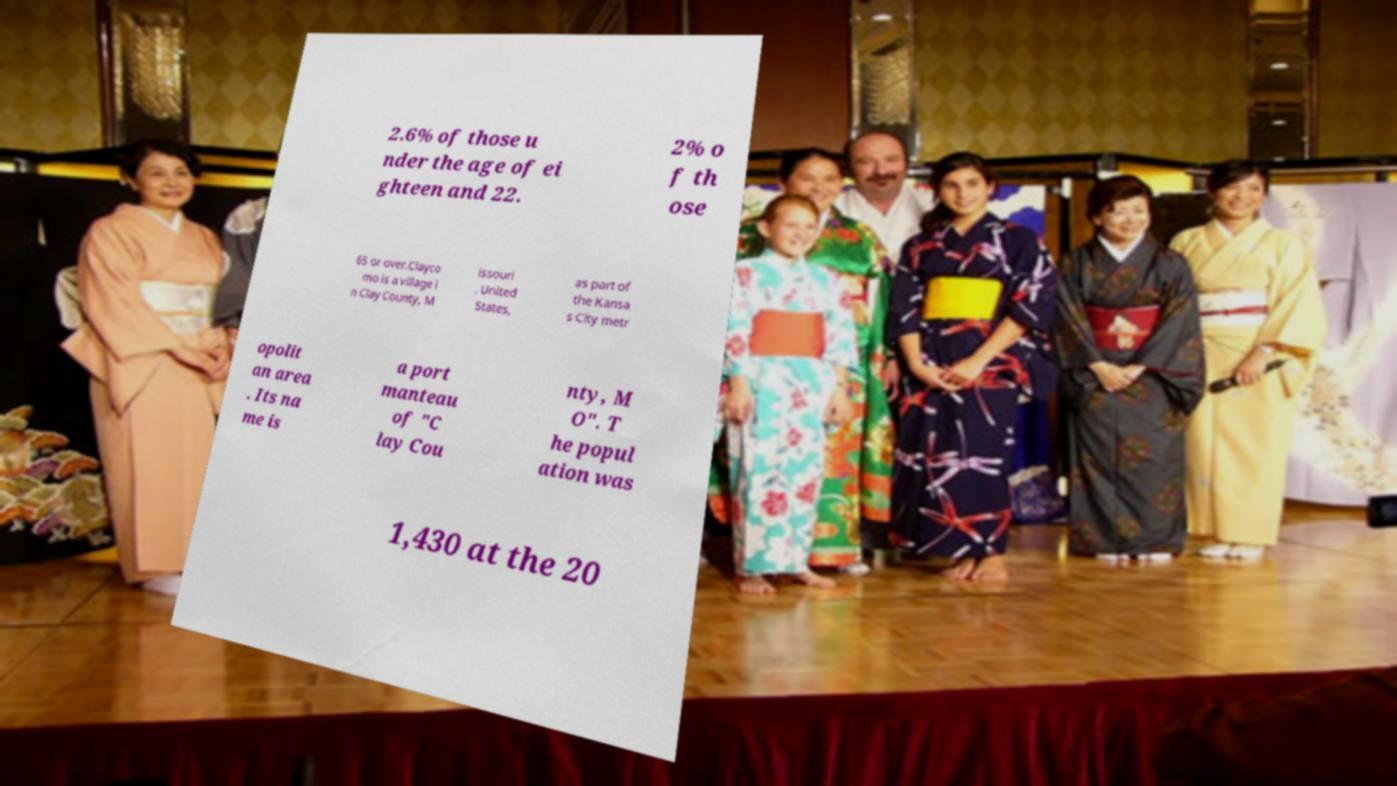I need the written content from this picture converted into text. Can you do that? 2.6% of those u nder the age of ei ghteen and 22. 2% o f th ose 65 or over.Clayco mo is a village i n Clay County, M issouri , United States, as part of the Kansa s City metr opolit an area . Its na me is a port manteau of "C lay Cou nty, M O". T he popul ation was 1,430 at the 20 